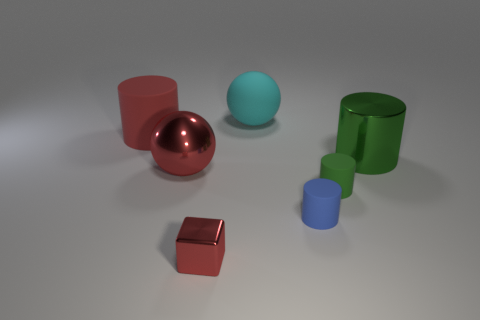There is a ball that is made of the same material as the red block; what is its size?
Make the answer very short. Large. Is the number of large red matte cylinders greater than the number of red objects?
Your response must be concise. No. What is the color of the sphere behind the large red sphere?
Your answer should be very brief. Cyan. There is a object that is both left of the blue thing and to the right of the small red shiny thing; what is its size?
Your response must be concise. Large. How many red cylinders are the same size as the blue thing?
Ensure brevity in your answer.  0. There is a red object that is the same shape as the tiny blue matte thing; what is its material?
Your answer should be compact. Rubber. Is the large cyan object the same shape as the small green object?
Your response must be concise. No. There is a tiny red shiny cube; what number of objects are to the left of it?
Provide a short and direct response. 2. There is a big metal object that is in front of the large thing that is right of the tiny green object; what is its shape?
Offer a very short reply. Sphere. What is the shape of the red object that is the same material as the cyan sphere?
Provide a short and direct response. Cylinder. 